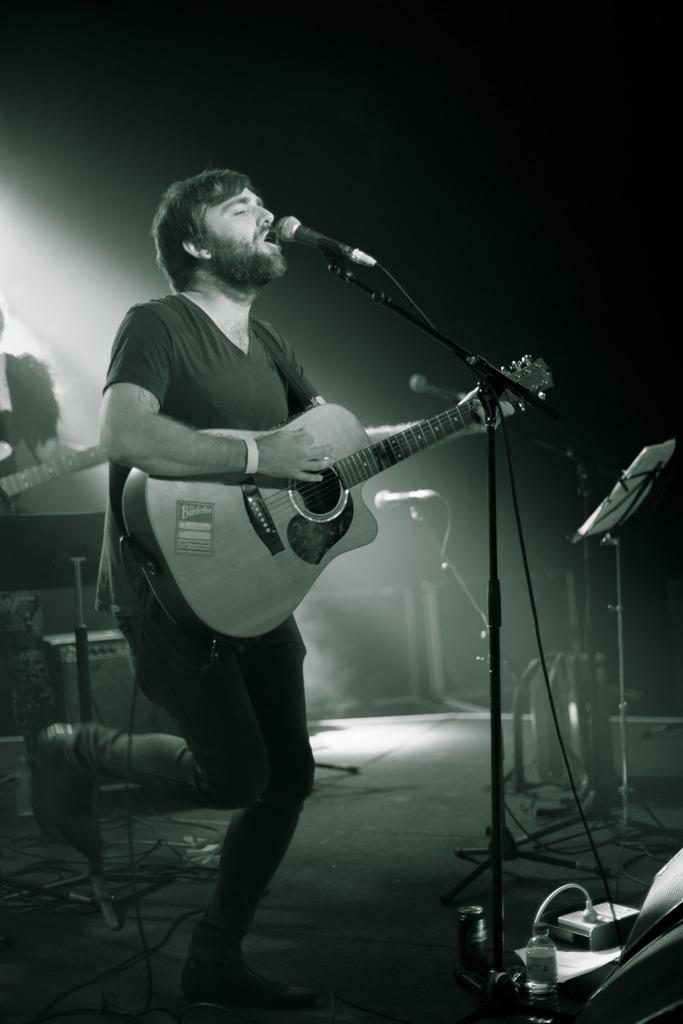What is the main subject of the image? The main subject of the image is a man. What is the man doing in the image? The man is standing, holding a guitar, and singing into a microphone. What can be seen in the background of the image? There are musical instruments and sound systems in the background. Can you see any fish swimming in the background of the image? No, there are no fish present in the image. Is the man wearing a ring on his finger in the image? The image does not provide information about any rings the man might be wearing. 